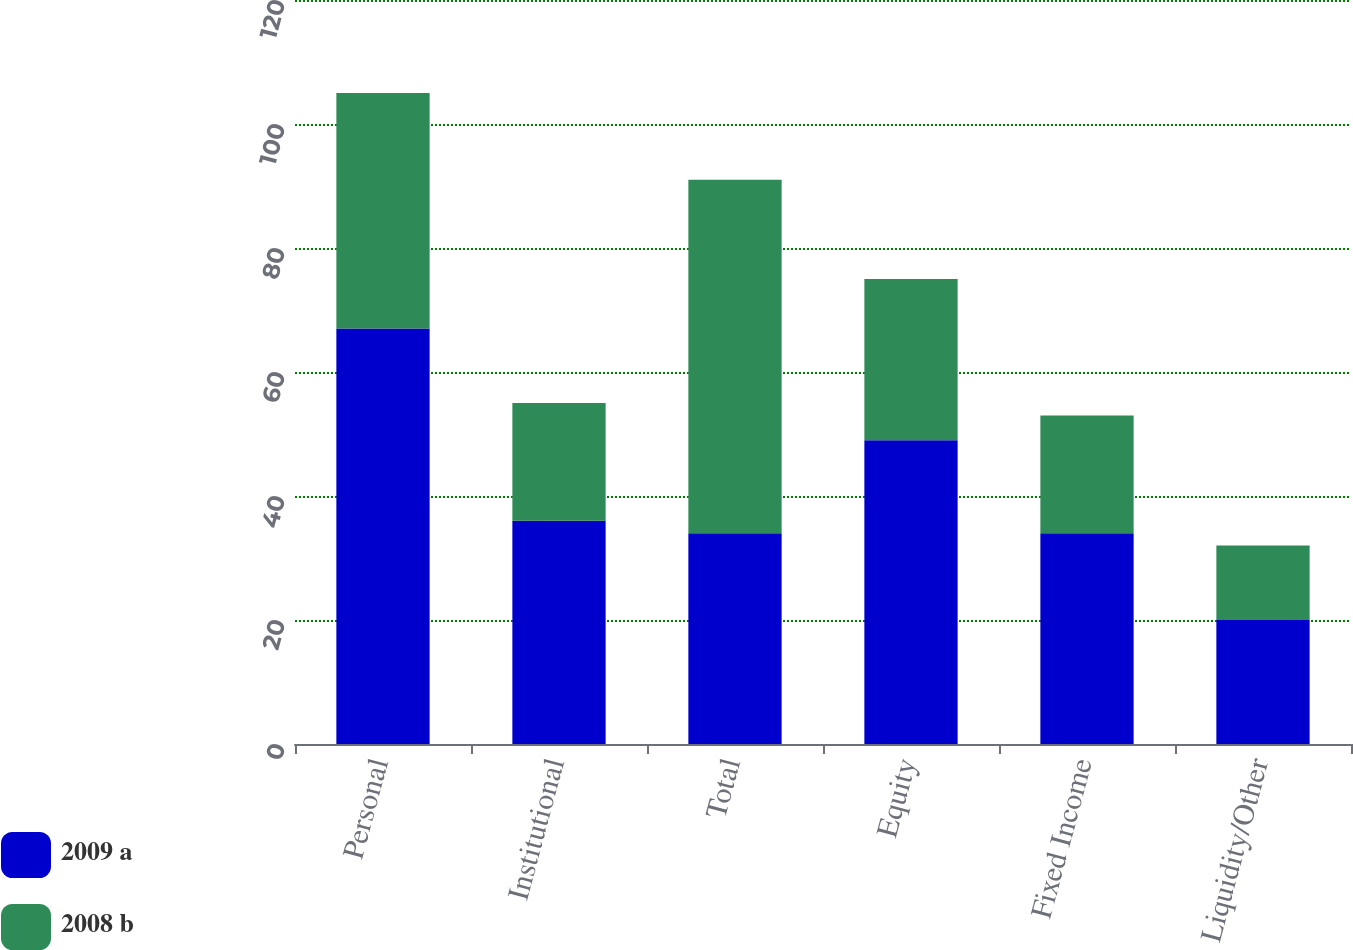<chart> <loc_0><loc_0><loc_500><loc_500><stacked_bar_chart><ecel><fcel>Personal<fcel>Institutional<fcel>Total<fcel>Equity<fcel>Fixed Income<fcel>Liquidity/Other<nl><fcel>2009 a<fcel>67<fcel>36<fcel>34<fcel>49<fcel>34<fcel>20<nl><fcel>2008 b<fcel>38<fcel>19<fcel>57<fcel>26<fcel>19<fcel>12<nl></chart> 